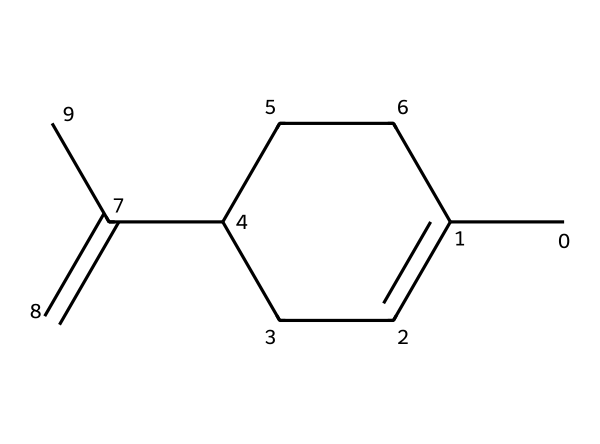What is the total number of carbon atoms in limonene? The SMILES representation shows a total of six carbon atoms (C). Each "C" in the structure corresponds to one carbon atom, and by counting them in the provided structure, we find six.
Answer: six How many double bonds are present in the limonene structure? The chemical structure contains one double bond as indicated by the "C(=C)" portion in the SMILES. This shows that there is a double bond between two carbon atoms.
Answer: one What functional group is indicated by the limonene structure? Limonene has a cycloalkene structure, primarily because it contains a ring and a double bond (C=C), which makes it a type of hydrocarbon with aliphatic and aromatic properties.
Answer: cycloalkene What is the molecular formula of limonene? To derive the molecular formula from the structure, we note that there are six carbon atoms and ten hydrogen atoms (C6H10) from the total count around the carbon framework and hydrogens directly attached.
Answer: C6H10 Which element predominantly characterizes limonene as a hydrocarbon? The predominant element characterizing limonene is carbon, as it comprises the backbone of the structure and defines it as a hydrocarbon.
Answer: carbon How does the presence of the double bond affect the reactivity of limonene? The presence of the double bond (C=C) makes limonene more reactive than saturated hydrocarbons, allowing it to participate in addition reactions due to the unsaturation in the structure.
Answer: more reactive What is the stereochemistry of limonene? Limonene exists in two enantiomeric forms, often referred to as D-limonene and L-limonene, indicating its chirality due to the presence of a chiral center in the structure, affecting its interaction with polarized light.
Answer: chiral 